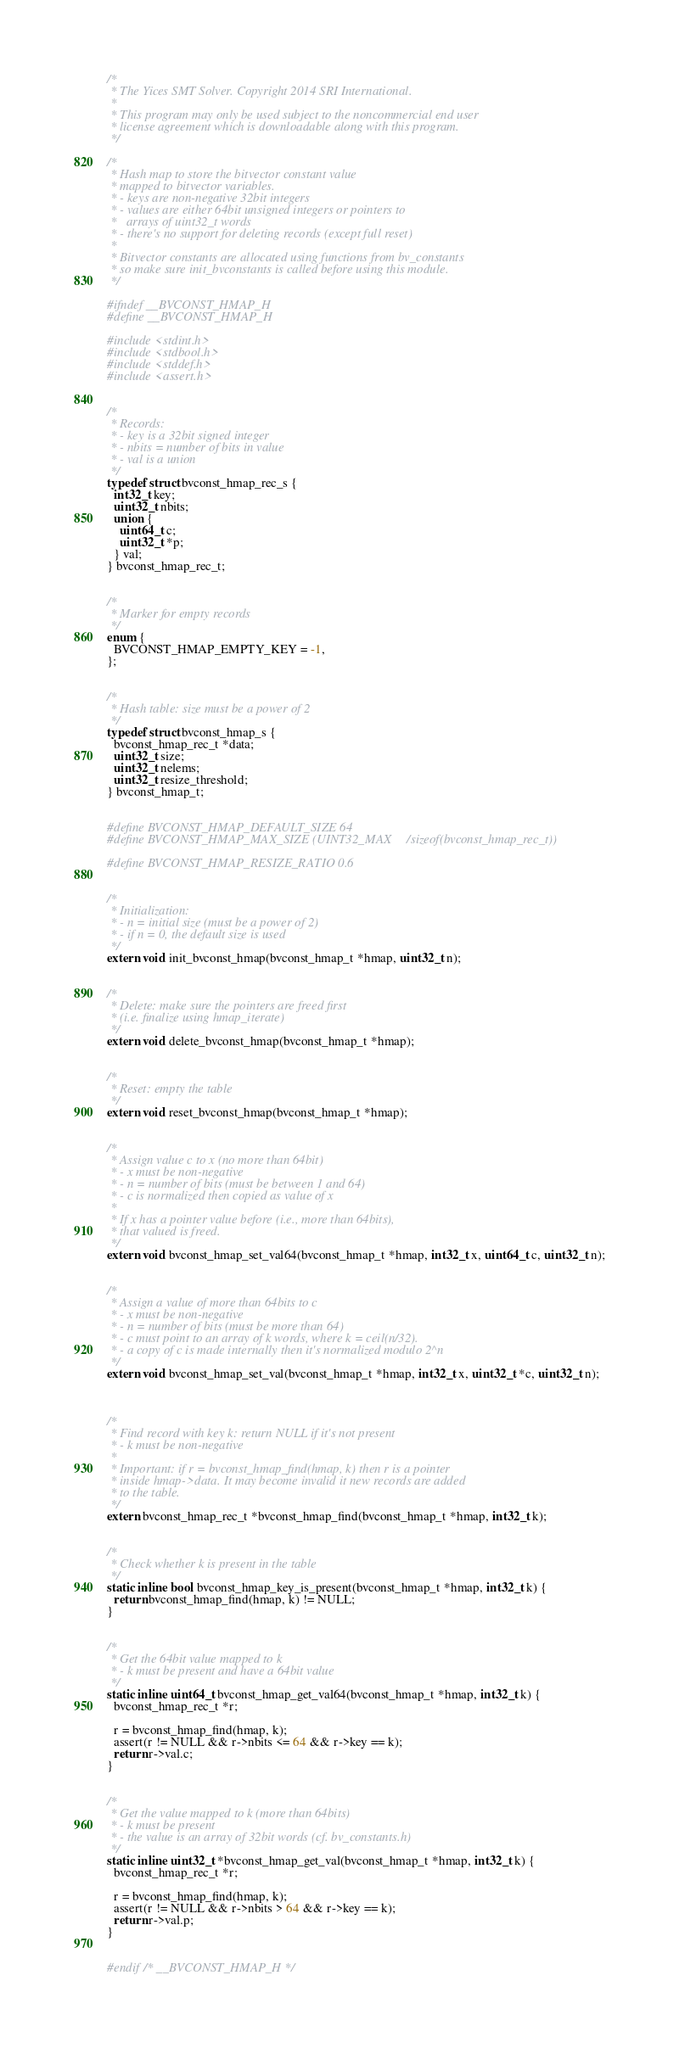Convert code to text. <code><loc_0><loc_0><loc_500><loc_500><_C_>/*
 * The Yices SMT Solver. Copyright 2014 SRI International.
 *
 * This program may only be used subject to the noncommercial end user
 * license agreement which is downloadable along with this program.
 */

/*
 * Hash map to store the bitvector constant value
 * mapped to bitvector variables.
 * - keys are non-negative 32bit integers
 * - values are either 64bit unsigned integers or pointers to
 *   arrays of uint32_t words
 * - there's no support for deleting records (except full reset)
 *
 * Bitvector constants are allocated using functions from bv_constants
 * so make sure init_bvconstants is called before using this module.
 */

#ifndef __BVCONST_HMAP_H
#define __BVCONST_HMAP_H

#include <stdint.h>
#include <stdbool.h>
#include <stddef.h>
#include <assert.h>


/*
 * Records:
 * - key is a 32bit signed integer
 * - nbits = number of bits in value
 * - val is a union
 */
typedef struct bvconst_hmap_rec_s {
  int32_t key;
  uint32_t nbits;
  union {
    uint64_t c;
    uint32_t *p;
  } val;
} bvconst_hmap_rec_t;


/*
 * Marker for empty records
 */
enum {
  BVCONST_HMAP_EMPTY_KEY = -1,
};


/*
 * Hash table: size must be a power of 2
 */
typedef struct bvconst_hmap_s {
  bvconst_hmap_rec_t *data;
  uint32_t size;
  uint32_t nelems;
  uint32_t resize_threshold;
} bvconst_hmap_t;


#define BVCONST_HMAP_DEFAULT_SIZE 64
#define BVCONST_HMAP_MAX_SIZE (UINT32_MAX/sizeof(bvconst_hmap_rec_t))

#define BVCONST_HMAP_RESIZE_RATIO 0.6


/*
 * Initialization:
 * - n = initial size (must be a power of 2)
 * - if n = 0, the default size is used
 */
extern void init_bvconst_hmap(bvconst_hmap_t *hmap, uint32_t n);


/*
 * Delete: make sure the pointers are freed first
 * (i.e. finalize using hmap_iterate)
 */
extern void delete_bvconst_hmap(bvconst_hmap_t *hmap);


/*
 * Reset: empty the table
 */
extern void reset_bvconst_hmap(bvconst_hmap_t *hmap);


/*
 * Assign value c to x (no more than 64bit)
 * - x must be non-negative
 * - n = number of bits (must be between 1 and 64)
 * - c is normalized then copied as value of x
 *
 * If x has a pointer value before (i.e., more than 64bits),
 * that valued is freed.
 */
extern void bvconst_hmap_set_val64(bvconst_hmap_t *hmap, int32_t x, uint64_t c, uint32_t n);


/*
 * Assign a value of more than 64bits to c
 * - x must be non-negative
 * - n = number of bits (must be more than 64)
 * - c must point to an array of k words, where k = ceil(n/32).
 * - a copy of c is made internally then it's normalized modulo 2^n
 */
extern void bvconst_hmap_set_val(bvconst_hmap_t *hmap, int32_t x, uint32_t *c, uint32_t n);



/*
 * Find record with key k: return NULL if it's not present
 * - k must be non-negative
 *
 * Important: if r = bvconst_hmap_find(hmap, k) then r is a pointer
 * inside hmap->data. It may become invalid it new records are added
 * to the table.
 */
extern bvconst_hmap_rec_t *bvconst_hmap_find(bvconst_hmap_t *hmap, int32_t k);


/*
 * Check whether k is present in the table
 */
static inline bool bvconst_hmap_key_is_present(bvconst_hmap_t *hmap, int32_t k) {
  return bvconst_hmap_find(hmap, k) != NULL;
}


/*
 * Get the 64bit value mapped to k
 * - k must be present and have a 64bit value
 */
static inline uint64_t bvconst_hmap_get_val64(bvconst_hmap_t *hmap, int32_t k) {
  bvconst_hmap_rec_t *r;

  r = bvconst_hmap_find(hmap, k);
  assert(r != NULL && r->nbits <= 64 && r->key == k);
  return r->val.c;
}


/*
 * Get the value mapped to k (more than 64bits)
 * - k must be present
 * - the value is an array of 32bit words (cf. bv_constants.h)
 */
static inline uint32_t *bvconst_hmap_get_val(bvconst_hmap_t *hmap, int32_t k) {
  bvconst_hmap_rec_t *r;

  r = bvconst_hmap_find(hmap, k);
  assert(r != NULL && r->nbits > 64 && r->key == k);
  return r->val.p;
}


#endif /* __BVCONST_HMAP_H */
</code> 